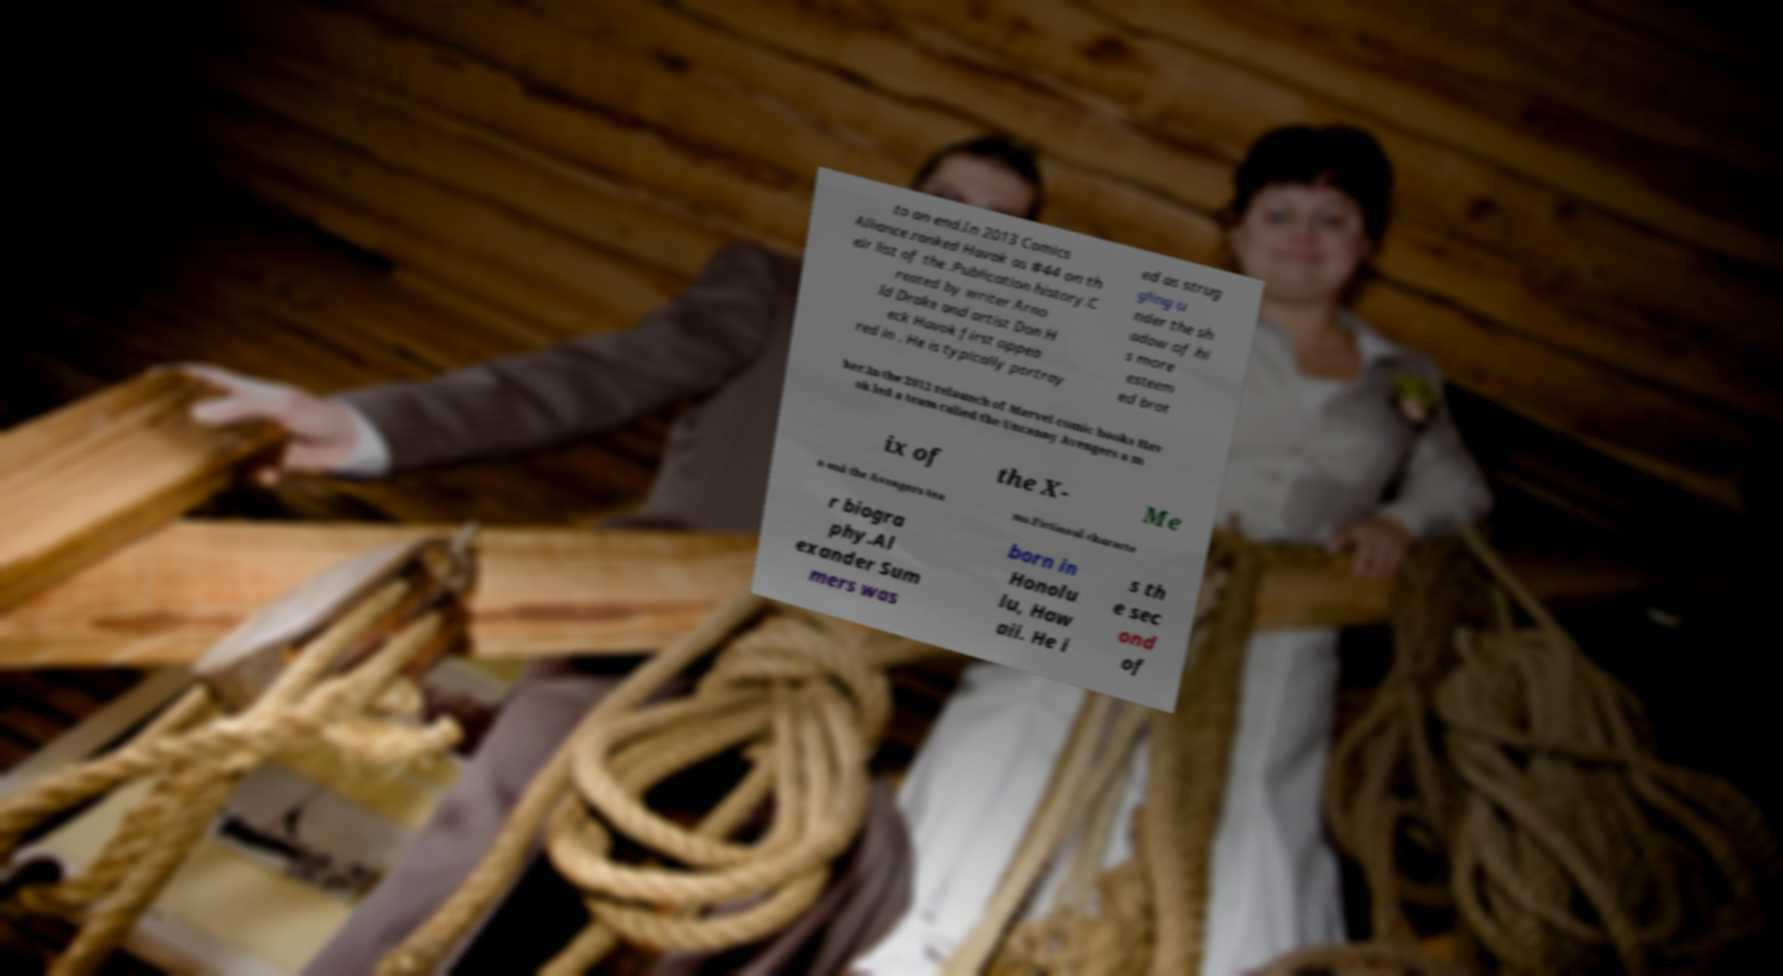Can you accurately transcribe the text from the provided image for me? to an end.In 2013 Comics Alliance ranked Havok as #44 on th eir list of the .Publication history.C reated by writer Arno ld Drake and artist Don H eck Havok first appea red in . He is typically portray ed as strug gling u nder the sh adow of hi s more esteem ed brot her.In the 2012 relaunch of Marvel comic books Hav ok led a team called the Uncanny Avengers a m ix of the X- Me n and the Avengers tea ms.Fictional characte r biogra phy.Al exander Sum mers was born in Honolu lu, Haw aii. He i s th e sec ond of 